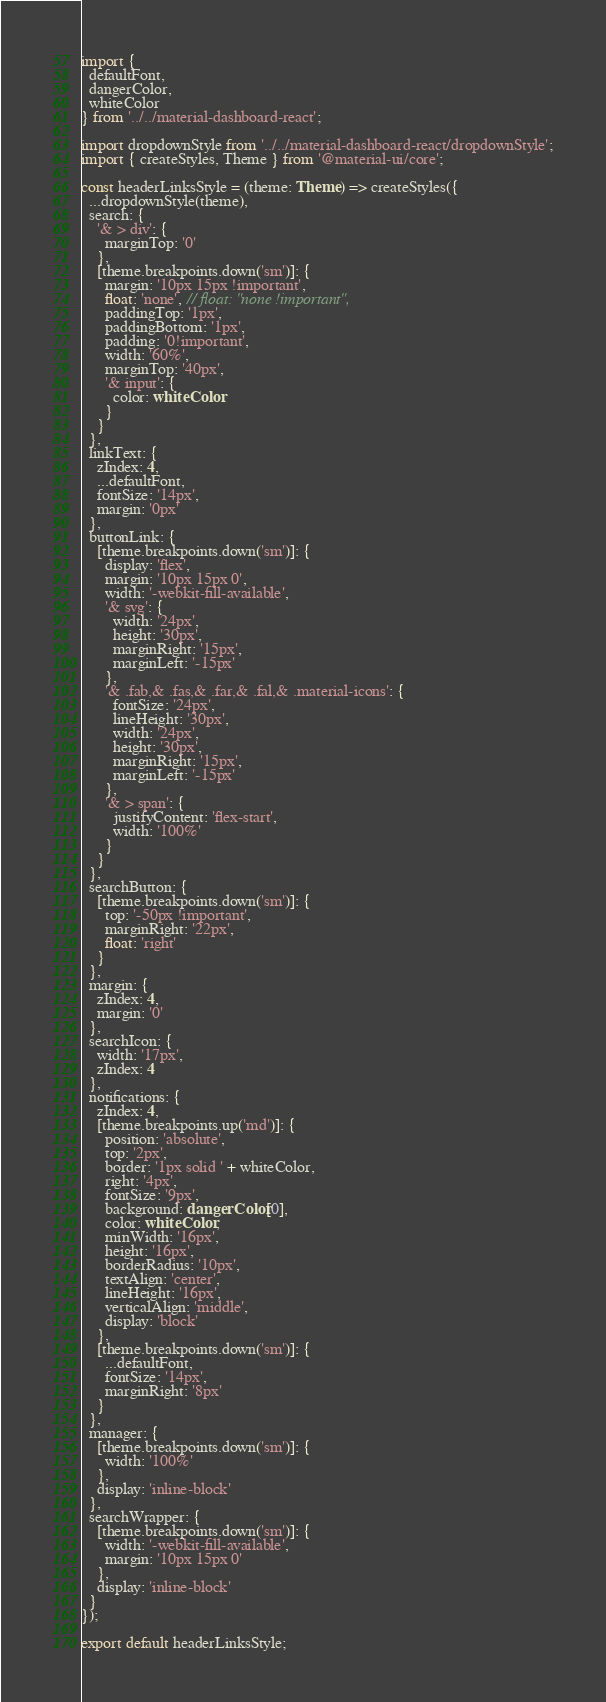<code> <loc_0><loc_0><loc_500><loc_500><_TypeScript_>import {
  defaultFont,
  dangerColor,
  whiteColor
} from '../../material-dashboard-react';

import dropdownStyle from '../../material-dashboard-react/dropdownStyle';
import { createStyles, Theme } from '@material-ui/core';

const headerLinksStyle = (theme: Theme) => createStyles({
  ...dropdownStyle(theme),
  search: {
    '& > div': {
      marginTop: '0'
    },
    [theme.breakpoints.down('sm')]: {
      margin: '10px 15px !important',
      float: 'none', // float: "none !important",
      paddingTop: '1px',
      paddingBottom: '1px',
      padding: '0!important',
      width: '60%',
      marginTop: '40px',
      '& input': {
        color: whiteColor
      }
    }
  },
  linkText: {
    zIndex: 4,
    ...defaultFont,
    fontSize: '14px',
    margin: '0px'
  },
  buttonLink: {
    [theme.breakpoints.down('sm')]: {
      display: 'flex',
      margin: '10px 15px 0',
      width: '-webkit-fill-available',
      '& svg': {
        width: '24px',
        height: '30px',
        marginRight: '15px',
        marginLeft: '-15px'
      },
      '& .fab,& .fas,& .far,& .fal,& .material-icons': {
        fontSize: '24px',
        lineHeight: '30px',
        width: '24px',
        height: '30px',
        marginRight: '15px',
        marginLeft: '-15px'
      },
      '& > span': {
        justifyContent: 'flex-start',
        width: '100%'
      }
    }
  },
  searchButton: {
    [theme.breakpoints.down('sm')]: {
      top: '-50px !important',
      marginRight: '22px',
      float: 'right'
    }
  },
  margin: {
    zIndex: 4,
    margin: '0'
  },
  searchIcon: {
    width: '17px',
    zIndex: 4
  },
  notifications: {
    zIndex: 4,
    [theme.breakpoints.up('md')]: {
      position: 'absolute',
      top: '2px',
      border: '1px solid ' + whiteColor,
      right: '4px',
      fontSize: '9px',
      background: dangerColor[0],
      color: whiteColor,
      minWidth: '16px',
      height: '16px',
      borderRadius: '10px',
      textAlign: 'center',
      lineHeight: '16px',
      verticalAlign: 'middle',
      display: 'block'
    },
    [theme.breakpoints.down('sm')]: {
      ...defaultFont,
      fontSize: '14px',
      marginRight: '8px'
    }
  },
  manager: {
    [theme.breakpoints.down('sm')]: {
      width: '100%'
    },
    display: 'inline-block'
  },
  searchWrapper: {
    [theme.breakpoints.down('sm')]: {
      width: '-webkit-fill-available',
      margin: '10px 15px 0'
    },
    display: 'inline-block'
  }
});

export default headerLinksStyle;
</code> 